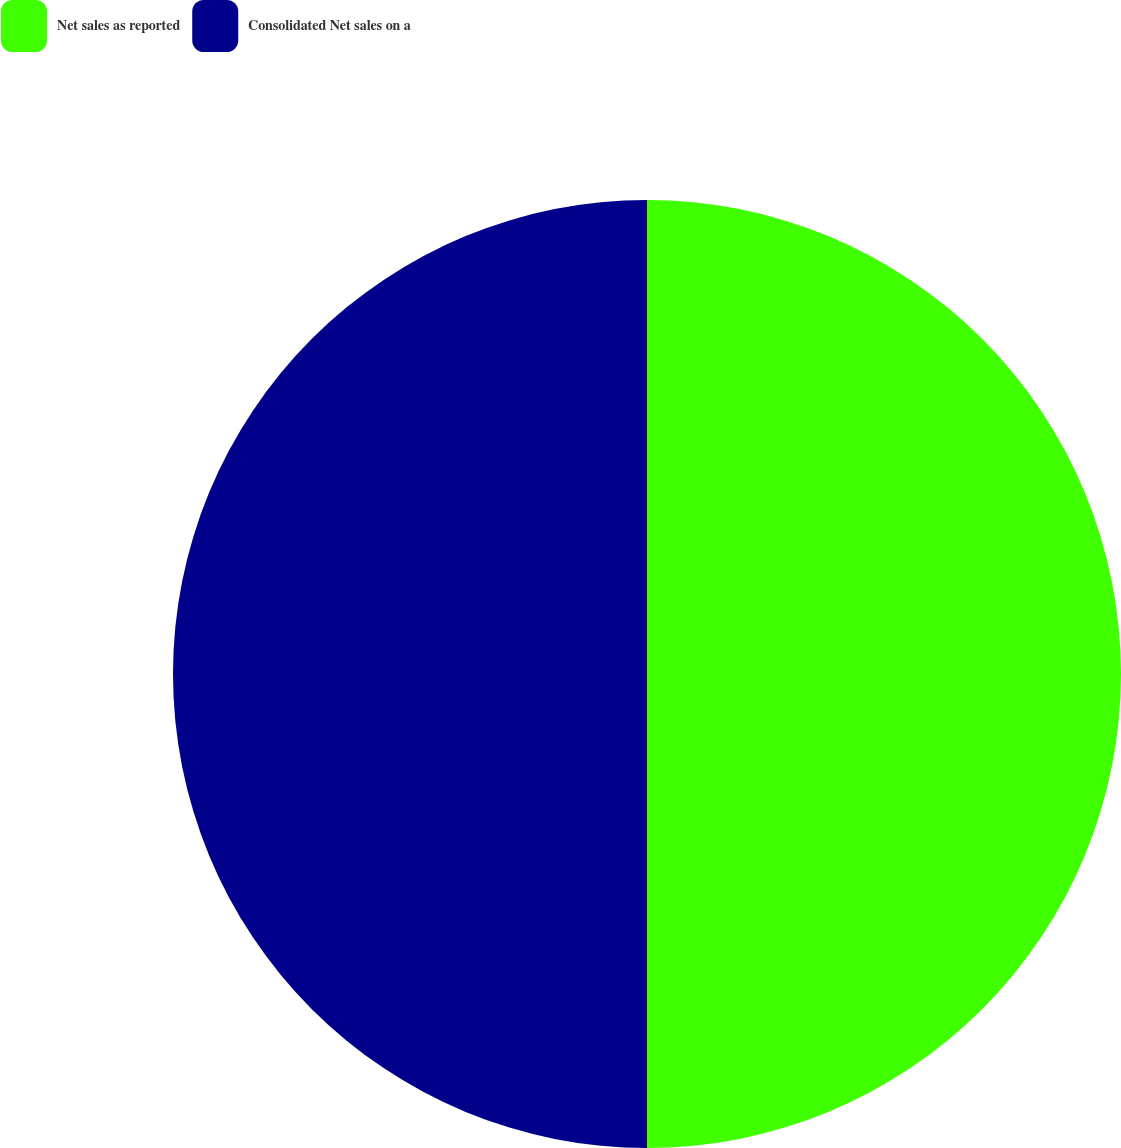Convert chart to OTSL. <chart><loc_0><loc_0><loc_500><loc_500><pie_chart><fcel>Net sales as reported<fcel>Consolidated Net sales on a<nl><fcel>50.0%<fcel>50.0%<nl></chart> 